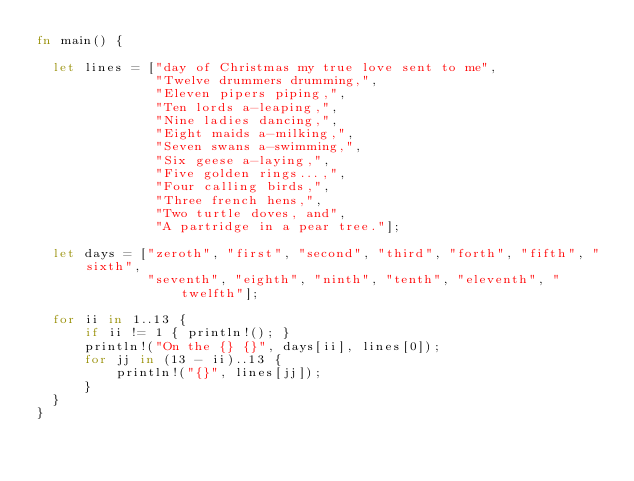<code> <loc_0><loc_0><loc_500><loc_500><_Rust_>fn main() {

  let lines = ["day of Christmas my true love sent to me",
               "Twelve drummers drumming,",
               "Eleven pipers piping,",
               "Ten lords a-leaping,",
               "Nine ladies dancing,",
               "Eight maids a-milking,",
               "Seven swans a-swimming,",
               "Six geese a-laying,",
               "Five golden rings...,",
               "Four calling birds,",
               "Three french hens,",
               "Two turtle doves, and",
               "A partridge in a pear tree."];

  let days = ["zeroth", "first", "second", "third", "forth", "fifth", "sixth",
              "seventh", "eighth", "ninth", "tenth", "eleventh", "twelfth"];

  for ii in 1..13 {
      if ii != 1 { println!(); }
      println!("On the {} {}", days[ii], lines[0]);
      for jj in (13 - ii)..13 {
          println!("{}", lines[jj]);
      }
  }
}
</code> 